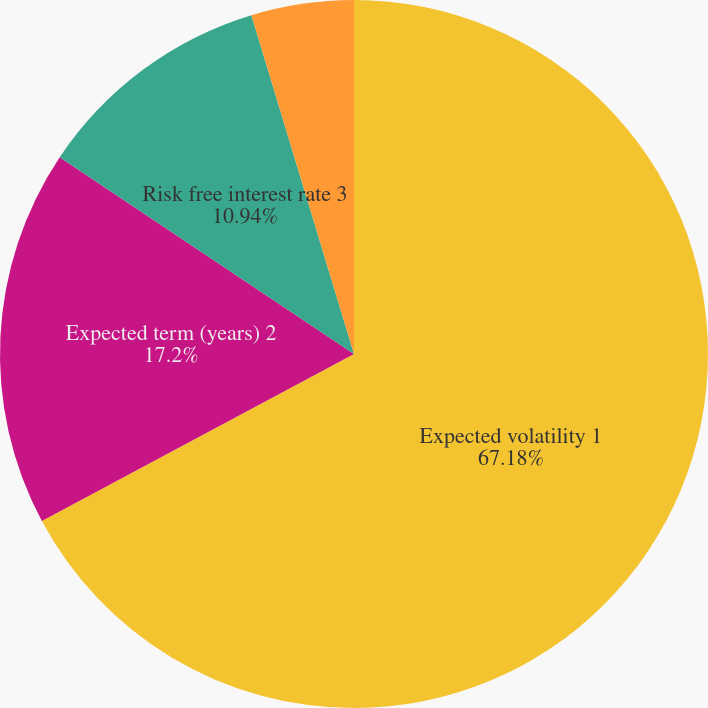Convert chart to OTSL. <chart><loc_0><loc_0><loc_500><loc_500><pie_chart><fcel>Expected volatility 1<fcel>Expected term (years) 2<fcel>Risk free interest rate 3<fcel>Expected dividend yield 4<nl><fcel>67.18%<fcel>17.2%<fcel>10.94%<fcel>4.68%<nl></chart> 